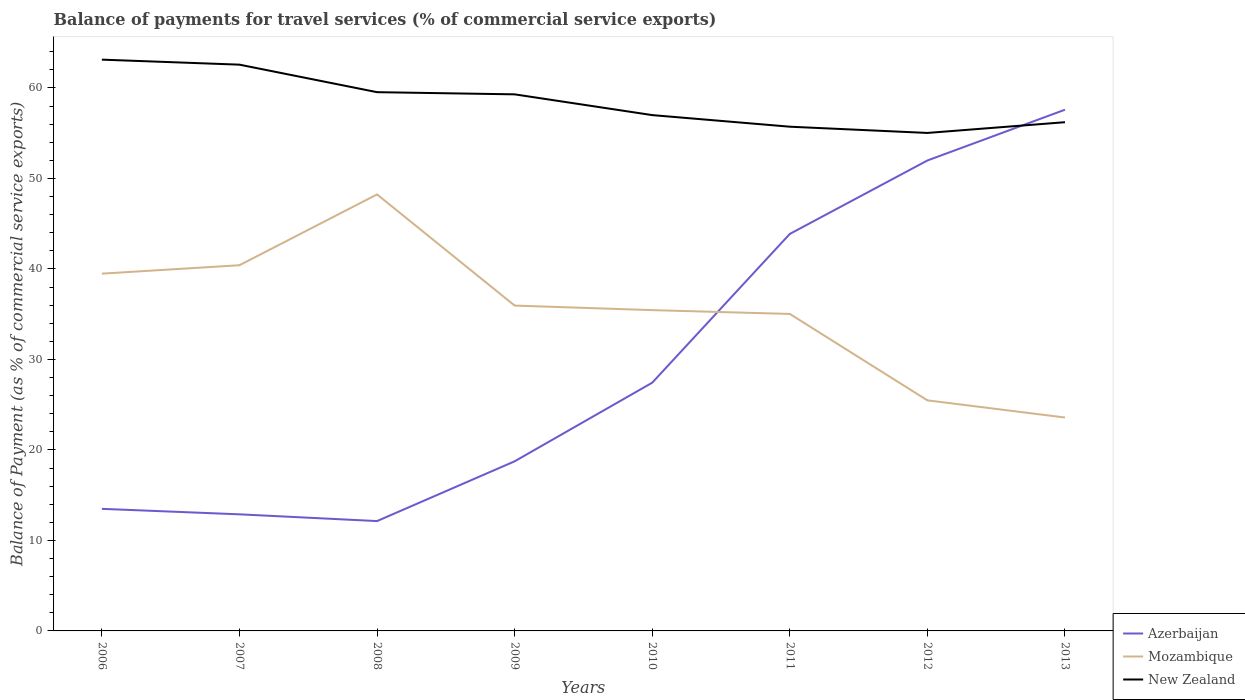How many different coloured lines are there?
Keep it short and to the point. 3. Does the line corresponding to New Zealand intersect with the line corresponding to Azerbaijan?
Provide a succinct answer. Yes. Is the number of lines equal to the number of legend labels?
Your response must be concise. Yes. Across all years, what is the maximum balance of payments for travel services in Azerbaijan?
Your response must be concise. 12.14. What is the total balance of payments for travel services in New Zealand in the graph?
Your answer should be compact. 7.41. What is the difference between the highest and the second highest balance of payments for travel services in New Zealand?
Provide a short and direct response. 8.1. What is the difference between the highest and the lowest balance of payments for travel services in New Zealand?
Your answer should be very brief. 4. How many lines are there?
Your response must be concise. 3. How many years are there in the graph?
Keep it short and to the point. 8. Does the graph contain grids?
Offer a terse response. No. How are the legend labels stacked?
Your answer should be very brief. Vertical. What is the title of the graph?
Your answer should be very brief. Balance of payments for travel services (% of commercial service exports). What is the label or title of the Y-axis?
Provide a succinct answer. Balance of Payment (as % of commercial service exports). What is the Balance of Payment (as % of commercial service exports) in Azerbaijan in 2006?
Offer a terse response. 13.49. What is the Balance of Payment (as % of commercial service exports) of Mozambique in 2006?
Make the answer very short. 39.48. What is the Balance of Payment (as % of commercial service exports) in New Zealand in 2006?
Provide a short and direct response. 63.13. What is the Balance of Payment (as % of commercial service exports) in Azerbaijan in 2007?
Provide a short and direct response. 12.88. What is the Balance of Payment (as % of commercial service exports) in Mozambique in 2007?
Offer a very short reply. 40.41. What is the Balance of Payment (as % of commercial service exports) in New Zealand in 2007?
Provide a short and direct response. 62.57. What is the Balance of Payment (as % of commercial service exports) in Azerbaijan in 2008?
Make the answer very short. 12.14. What is the Balance of Payment (as % of commercial service exports) in Mozambique in 2008?
Offer a very short reply. 48.23. What is the Balance of Payment (as % of commercial service exports) of New Zealand in 2008?
Provide a succinct answer. 59.53. What is the Balance of Payment (as % of commercial service exports) of Azerbaijan in 2009?
Your answer should be compact. 18.74. What is the Balance of Payment (as % of commercial service exports) of Mozambique in 2009?
Offer a terse response. 35.95. What is the Balance of Payment (as % of commercial service exports) in New Zealand in 2009?
Give a very brief answer. 59.29. What is the Balance of Payment (as % of commercial service exports) of Azerbaijan in 2010?
Your answer should be compact. 27.43. What is the Balance of Payment (as % of commercial service exports) of Mozambique in 2010?
Keep it short and to the point. 35.45. What is the Balance of Payment (as % of commercial service exports) in New Zealand in 2010?
Make the answer very short. 57. What is the Balance of Payment (as % of commercial service exports) of Azerbaijan in 2011?
Your response must be concise. 43.87. What is the Balance of Payment (as % of commercial service exports) of Mozambique in 2011?
Your answer should be very brief. 35.03. What is the Balance of Payment (as % of commercial service exports) of New Zealand in 2011?
Your answer should be compact. 55.72. What is the Balance of Payment (as % of commercial service exports) in Azerbaijan in 2012?
Provide a short and direct response. 51.98. What is the Balance of Payment (as % of commercial service exports) in Mozambique in 2012?
Your response must be concise. 25.48. What is the Balance of Payment (as % of commercial service exports) of New Zealand in 2012?
Make the answer very short. 55.03. What is the Balance of Payment (as % of commercial service exports) of Azerbaijan in 2013?
Offer a terse response. 57.59. What is the Balance of Payment (as % of commercial service exports) in Mozambique in 2013?
Provide a succinct answer. 23.58. What is the Balance of Payment (as % of commercial service exports) in New Zealand in 2013?
Offer a very short reply. 56.21. Across all years, what is the maximum Balance of Payment (as % of commercial service exports) in Azerbaijan?
Provide a short and direct response. 57.59. Across all years, what is the maximum Balance of Payment (as % of commercial service exports) of Mozambique?
Ensure brevity in your answer.  48.23. Across all years, what is the maximum Balance of Payment (as % of commercial service exports) of New Zealand?
Offer a very short reply. 63.13. Across all years, what is the minimum Balance of Payment (as % of commercial service exports) of Azerbaijan?
Provide a short and direct response. 12.14. Across all years, what is the minimum Balance of Payment (as % of commercial service exports) in Mozambique?
Offer a very short reply. 23.58. Across all years, what is the minimum Balance of Payment (as % of commercial service exports) in New Zealand?
Make the answer very short. 55.03. What is the total Balance of Payment (as % of commercial service exports) in Azerbaijan in the graph?
Your answer should be compact. 238.13. What is the total Balance of Payment (as % of commercial service exports) of Mozambique in the graph?
Offer a terse response. 283.61. What is the total Balance of Payment (as % of commercial service exports) of New Zealand in the graph?
Your answer should be compact. 468.48. What is the difference between the Balance of Payment (as % of commercial service exports) of Azerbaijan in 2006 and that in 2007?
Provide a short and direct response. 0.61. What is the difference between the Balance of Payment (as % of commercial service exports) in Mozambique in 2006 and that in 2007?
Provide a succinct answer. -0.93. What is the difference between the Balance of Payment (as % of commercial service exports) in New Zealand in 2006 and that in 2007?
Provide a succinct answer. 0.55. What is the difference between the Balance of Payment (as % of commercial service exports) of Azerbaijan in 2006 and that in 2008?
Give a very brief answer. 1.35. What is the difference between the Balance of Payment (as % of commercial service exports) in Mozambique in 2006 and that in 2008?
Keep it short and to the point. -8.75. What is the difference between the Balance of Payment (as % of commercial service exports) of New Zealand in 2006 and that in 2008?
Your answer should be very brief. 3.59. What is the difference between the Balance of Payment (as % of commercial service exports) in Azerbaijan in 2006 and that in 2009?
Your answer should be very brief. -5.25. What is the difference between the Balance of Payment (as % of commercial service exports) in Mozambique in 2006 and that in 2009?
Your answer should be compact. 3.53. What is the difference between the Balance of Payment (as % of commercial service exports) of New Zealand in 2006 and that in 2009?
Ensure brevity in your answer.  3.83. What is the difference between the Balance of Payment (as % of commercial service exports) of Azerbaijan in 2006 and that in 2010?
Give a very brief answer. -13.94. What is the difference between the Balance of Payment (as % of commercial service exports) in Mozambique in 2006 and that in 2010?
Make the answer very short. 4.03. What is the difference between the Balance of Payment (as % of commercial service exports) of New Zealand in 2006 and that in 2010?
Your answer should be very brief. 6.13. What is the difference between the Balance of Payment (as % of commercial service exports) of Azerbaijan in 2006 and that in 2011?
Provide a succinct answer. -30.38. What is the difference between the Balance of Payment (as % of commercial service exports) of Mozambique in 2006 and that in 2011?
Your answer should be compact. 4.45. What is the difference between the Balance of Payment (as % of commercial service exports) in New Zealand in 2006 and that in 2011?
Keep it short and to the point. 7.41. What is the difference between the Balance of Payment (as % of commercial service exports) in Azerbaijan in 2006 and that in 2012?
Your response must be concise. -38.49. What is the difference between the Balance of Payment (as % of commercial service exports) in Mozambique in 2006 and that in 2012?
Ensure brevity in your answer.  14. What is the difference between the Balance of Payment (as % of commercial service exports) of New Zealand in 2006 and that in 2012?
Provide a succinct answer. 8.1. What is the difference between the Balance of Payment (as % of commercial service exports) of Azerbaijan in 2006 and that in 2013?
Keep it short and to the point. -44.11. What is the difference between the Balance of Payment (as % of commercial service exports) of Mozambique in 2006 and that in 2013?
Your answer should be very brief. 15.9. What is the difference between the Balance of Payment (as % of commercial service exports) of New Zealand in 2006 and that in 2013?
Provide a succinct answer. 6.91. What is the difference between the Balance of Payment (as % of commercial service exports) of Azerbaijan in 2007 and that in 2008?
Provide a short and direct response. 0.75. What is the difference between the Balance of Payment (as % of commercial service exports) in Mozambique in 2007 and that in 2008?
Provide a succinct answer. -7.82. What is the difference between the Balance of Payment (as % of commercial service exports) in New Zealand in 2007 and that in 2008?
Provide a succinct answer. 3.04. What is the difference between the Balance of Payment (as % of commercial service exports) of Azerbaijan in 2007 and that in 2009?
Ensure brevity in your answer.  -5.86. What is the difference between the Balance of Payment (as % of commercial service exports) in Mozambique in 2007 and that in 2009?
Provide a short and direct response. 4.46. What is the difference between the Balance of Payment (as % of commercial service exports) in New Zealand in 2007 and that in 2009?
Give a very brief answer. 3.28. What is the difference between the Balance of Payment (as % of commercial service exports) of Azerbaijan in 2007 and that in 2010?
Give a very brief answer. -14.55. What is the difference between the Balance of Payment (as % of commercial service exports) in Mozambique in 2007 and that in 2010?
Your answer should be compact. 4.96. What is the difference between the Balance of Payment (as % of commercial service exports) in New Zealand in 2007 and that in 2010?
Offer a terse response. 5.57. What is the difference between the Balance of Payment (as % of commercial service exports) of Azerbaijan in 2007 and that in 2011?
Make the answer very short. -30.99. What is the difference between the Balance of Payment (as % of commercial service exports) of Mozambique in 2007 and that in 2011?
Your answer should be compact. 5.38. What is the difference between the Balance of Payment (as % of commercial service exports) of New Zealand in 2007 and that in 2011?
Offer a terse response. 6.86. What is the difference between the Balance of Payment (as % of commercial service exports) in Azerbaijan in 2007 and that in 2012?
Offer a terse response. -39.1. What is the difference between the Balance of Payment (as % of commercial service exports) of Mozambique in 2007 and that in 2012?
Provide a short and direct response. 14.93. What is the difference between the Balance of Payment (as % of commercial service exports) in New Zealand in 2007 and that in 2012?
Your response must be concise. 7.55. What is the difference between the Balance of Payment (as % of commercial service exports) in Azerbaijan in 2007 and that in 2013?
Make the answer very short. -44.71. What is the difference between the Balance of Payment (as % of commercial service exports) in Mozambique in 2007 and that in 2013?
Make the answer very short. 16.83. What is the difference between the Balance of Payment (as % of commercial service exports) in New Zealand in 2007 and that in 2013?
Make the answer very short. 6.36. What is the difference between the Balance of Payment (as % of commercial service exports) of Azerbaijan in 2008 and that in 2009?
Ensure brevity in your answer.  -6.6. What is the difference between the Balance of Payment (as % of commercial service exports) in Mozambique in 2008 and that in 2009?
Keep it short and to the point. 12.28. What is the difference between the Balance of Payment (as % of commercial service exports) in New Zealand in 2008 and that in 2009?
Ensure brevity in your answer.  0.24. What is the difference between the Balance of Payment (as % of commercial service exports) in Azerbaijan in 2008 and that in 2010?
Keep it short and to the point. -15.29. What is the difference between the Balance of Payment (as % of commercial service exports) of Mozambique in 2008 and that in 2010?
Your answer should be very brief. 12.79. What is the difference between the Balance of Payment (as % of commercial service exports) in New Zealand in 2008 and that in 2010?
Give a very brief answer. 2.53. What is the difference between the Balance of Payment (as % of commercial service exports) of Azerbaijan in 2008 and that in 2011?
Provide a succinct answer. -31.73. What is the difference between the Balance of Payment (as % of commercial service exports) in Mozambique in 2008 and that in 2011?
Your answer should be very brief. 13.21. What is the difference between the Balance of Payment (as % of commercial service exports) in New Zealand in 2008 and that in 2011?
Provide a short and direct response. 3.81. What is the difference between the Balance of Payment (as % of commercial service exports) of Azerbaijan in 2008 and that in 2012?
Make the answer very short. -39.85. What is the difference between the Balance of Payment (as % of commercial service exports) in Mozambique in 2008 and that in 2012?
Your response must be concise. 22.76. What is the difference between the Balance of Payment (as % of commercial service exports) of New Zealand in 2008 and that in 2012?
Offer a terse response. 4.5. What is the difference between the Balance of Payment (as % of commercial service exports) of Azerbaijan in 2008 and that in 2013?
Your answer should be very brief. -45.46. What is the difference between the Balance of Payment (as % of commercial service exports) in Mozambique in 2008 and that in 2013?
Your answer should be compact. 24.65. What is the difference between the Balance of Payment (as % of commercial service exports) of New Zealand in 2008 and that in 2013?
Offer a terse response. 3.32. What is the difference between the Balance of Payment (as % of commercial service exports) of Azerbaijan in 2009 and that in 2010?
Your response must be concise. -8.69. What is the difference between the Balance of Payment (as % of commercial service exports) of Mozambique in 2009 and that in 2010?
Make the answer very short. 0.5. What is the difference between the Balance of Payment (as % of commercial service exports) of New Zealand in 2009 and that in 2010?
Provide a short and direct response. 2.29. What is the difference between the Balance of Payment (as % of commercial service exports) in Azerbaijan in 2009 and that in 2011?
Offer a very short reply. -25.13. What is the difference between the Balance of Payment (as % of commercial service exports) of Mozambique in 2009 and that in 2011?
Provide a short and direct response. 0.92. What is the difference between the Balance of Payment (as % of commercial service exports) of New Zealand in 2009 and that in 2011?
Make the answer very short. 3.58. What is the difference between the Balance of Payment (as % of commercial service exports) in Azerbaijan in 2009 and that in 2012?
Provide a succinct answer. -33.24. What is the difference between the Balance of Payment (as % of commercial service exports) of Mozambique in 2009 and that in 2012?
Your answer should be very brief. 10.47. What is the difference between the Balance of Payment (as % of commercial service exports) in New Zealand in 2009 and that in 2012?
Ensure brevity in your answer.  4.26. What is the difference between the Balance of Payment (as % of commercial service exports) of Azerbaijan in 2009 and that in 2013?
Make the answer very short. -38.85. What is the difference between the Balance of Payment (as % of commercial service exports) of Mozambique in 2009 and that in 2013?
Offer a terse response. 12.37. What is the difference between the Balance of Payment (as % of commercial service exports) in New Zealand in 2009 and that in 2013?
Your response must be concise. 3.08. What is the difference between the Balance of Payment (as % of commercial service exports) of Azerbaijan in 2010 and that in 2011?
Give a very brief answer. -16.44. What is the difference between the Balance of Payment (as % of commercial service exports) in Mozambique in 2010 and that in 2011?
Offer a terse response. 0.42. What is the difference between the Balance of Payment (as % of commercial service exports) in New Zealand in 2010 and that in 2011?
Provide a succinct answer. 1.28. What is the difference between the Balance of Payment (as % of commercial service exports) in Azerbaijan in 2010 and that in 2012?
Offer a terse response. -24.55. What is the difference between the Balance of Payment (as % of commercial service exports) in Mozambique in 2010 and that in 2012?
Offer a very short reply. 9.97. What is the difference between the Balance of Payment (as % of commercial service exports) in New Zealand in 2010 and that in 2012?
Your response must be concise. 1.97. What is the difference between the Balance of Payment (as % of commercial service exports) of Azerbaijan in 2010 and that in 2013?
Provide a succinct answer. -30.17. What is the difference between the Balance of Payment (as % of commercial service exports) in Mozambique in 2010 and that in 2013?
Ensure brevity in your answer.  11.87. What is the difference between the Balance of Payment (as % of commercial service exports) of New Zealand in 2010 and that in 2013?
Your response must be concise. 0.78. What is the difference between the Balance of Payment (as % of commercial service exports) in Azerbaijan in 2011 and that in 2012?
Ensure brevity in your answer.  -8.11. What is the difference between the Balance of Payment (as % of commercial service exports) in Mozambique in 2011 and that in 2012?
Provide a succinct answer. 9.55. What is the difference between the Balance of Payment (as % of commercial service exports) in New Zealand in 2011 and that in 2012?
Your response must be concise. 0.69. What is the difference between the Balance of Payment (as % of commercial service exports) in Azerbaijan in 2011 and that in 2013?
Your response must be concise. -13.72. What is the difference between the Balance of Payment (as % of commercial service exports) of Mozambique in 2011 and that in 2013?
Provide a succinct answer. 11.45. What is the difference between the Balance of Payment (as % of commercial service exports) of New Zealand in 2011 and that in 2013?
Ensure brevity in your answer.  -0.5. What is the difference between the Balance of Payment (as % of commercial service exports) of Azerbaijan in 2012 and that in 2013?
Your answer should be compact. -5.61. What is the difference between the Balance of Payment (as % of commercial service exports) of Mozambique in 2012 and that in 2013?
Your answer should be compact. 1.9. What is the difference between the Balance of Payment (as % of commercial service exports) of New Zealand in 2012 and that in 2013?
Your response must be concise. -1.19. What is the difference between the Balance of Payment (as % of commercial service exports) of Azerbaijan in 2006 and the Balance of Payment (as % of commercial service exports) of Mozambique in 2007?
Keep it short and to the point. -26.92. What is the difference between the Balance of Payment (as % of commercial service exports) of Azerbaijan in 2006 and the Balance of Payment (as % of commercial service exports) of New Zealand in 2007?
Offer a terse response. -49.08. What is the difference between the Balance of Payment (as % of commercial service exports) in Mozambique in 2006 and the Balance of Payment (as % of commercial service exports) in New Zealand in 2007?
Your response must be concise. -23.09. What is the difference between the Balance of Payment (as % of commercial service exports) in Azerbaijan in 2006 and the Balance of Payment (as % of commercial service exports) in Mozambique in 2008?
Your answer should be compact. -34.74. What is the difference between the Balance of Payment (as % of commercial service exports) of Azerbaijan in 2006 and the Balance of Payment (as % of commercial service exports) of New Zealand in 2008?
Offer a very short reply. -46.04. What is the difference between the Balance of Payment (as % of commercial service exports) of Mozambique in 2006 and the Balance of Payment (as % of commercial service exports) of New Zealand in 2008?
Ensure brevity in your answer.  -20.05. What is the difference between the Balance of Payment (as % of commercial service exports) of Azerbaijan in 2006 and the Balance of Payment (as % of commercial service exports) of Mozambique in 2009?
Offer a terse response. -22.46. What is the difference between the Balance of Payment (as % of commercial service exports) in Azerbaijan in 2006 and the Balance of Payment (as % of commercial service exports) in New Zealand in 2009?
Offer a very short reply. -45.8. What is the difference between the Balance of Payment (as % of commercial service exports) of Mozambique in 2006 and the Balance of Payment (as % of commercial service exports) of New Zealand in 2009?
Ensure brevity in your answer.  -19.81. What is the difference between the Balance of Payment (as % of commercial service exports) in Azerbaijan in 2006 and the Balance of Payment (as % of commercial service exports) in Mozambique in 2010?
Give a very brief answer. -21.96. What is the difference between the Balance of Payment (as % of commercial service exports) of Azerbaijan in 2006 and the Balance of Payment (as % of commercial service exports) of New Zealand in 2010?
Your answer should be very brief. -43.51. What is the difference between the Balance of Payment (as % of commercial service exports) of Mozambique in 2006 and the Balance of Payment (as % of commercial service exports) of New Zealand in 2010?
Give a very brief answer. -17.52. What is the difference between the Balance of Payment (as % of commercial service exports) in Azerbaijan in 2006 and the Balance of Payment (as % of commercial service exports) in Mozambique in 2011?
Your response must be concise. -21.54. What is the difference between the Balance of Payment (as % of commercial service exports) of Azerbaijan in 2006 and the Balance of Payment (as % of commercial service exports) of New Zealand in 2011?
Offer a very short reply. -42.23. What is the difference between the Balance of Payment (as % of commercial service exports) of Mozambique in 2006 and the Balance of Payment (as % of commercial service exports) of New Zealand in 2011?
Provide a succinct answer. -16.24. What is the difference between the Balance of Payment (as % of commercial service exports) in Azerbaijan in 2006 and the Balance of Payment (as % of commercial service exports) in Mozambique in 2012?
Offer a very short reply. -11.99. What is the difference between the Balance of Payment (as % of commercial service exports) in Azerbaijan in 2006 and the Balance of Payment (as % of commercial service exports) in New Zealand in 2012?
Ensure brevity in your answer.  -41.54. What is the difference between the Balance of Payment (as % of commercial service exports) in Mozambique in 2006 and the Balance of Payment (as % of commercial service exports) in New Zealand in 2012?
Offer a very short reply. -15.55. What is the difference between the Balance of Payment (as % of commercial service exports) of Azerbaijan in 2006 and the Balance of Payment (as % of commercial service exports) of Mozambique in 2013?
Make the answer very short. -10.09. What is the difference between the Balance of Payment (as % of commercial service exports) of Azerbaijan in 2006 and the Balance of Payment (as % of commercial service exports) of New Zealand in 2013?
Your answer should be compact. -42.72. What is the difference between the Balance of Payment (as % of commercial service exports) in Mozambique in 2006 and the Balance of Payment (as % of commercial service exports) in New Zealand in 2013?
Keep it short and to the point. -16.73. What is the difference between the Balance of Payment (as % of commercial service exports) of Azerbaijan in 2007 and the Balance of Payment (as % of commercial service exports) of Mozambique in 2008?
Offer a terse response. -35.35. What is the difference between the Balance of Payment (as % of commercial service exports) in Azerbaijan in 2007 and the Balance of Payment (as % of commercial service exports) in New Zealand in 2008?
Provide a short and direct response. -46.65. What is the difference between the Balance of Payment (as % of commercial service exports) in Mozambique in 2007 and the Balance of Payment (as % of commercial service exports) in New Zealand in 2008?
Make the answer very short. -19.12. What is the difference between the Balance of Payment (as % of commercial service exports) in Azerbaijan in 2007 and the Balance of Payment (as % of commercial service exports) in Mozambique in 2009?
Your answer should be very brief. -23.07. What is the difference between the Balance of Payment (as % of commercial service exports) of Azerbaijan in 2007 and the Balance of Payment (as % of commercial service exports) of New Zealand in 2009?
Ensure brevity in your answer.  -46.41. What is the difference between the Balance of Payment (as % of commercial service exports) in Mozambique in 2007 and the Balance of Payment (as % of commercial service exports) in New Zealand in 2009?
Give a very brief answer. -18.88. What is the difference between the Balance of Payment (as % of commercial service exports) in Azerbaijan in 2007 and the Balance of Payment (as % of commercial service exports) in Mozambique in 2010?
Your response must be concise. -22.56. What is the difference between the Balance of Payment (as % of commercial service exports) in Azerbaijan in 2007 and the Balance of Payment (as % of commercial service exports) in New Zealand in 2010?
Give a very brief answer. -44.11. What is the difference between the Balance of Payment (as % of commercial service exports) of Mozambique in 2007 and the Balance of Payment (as % of commercial service exports) of New Zealand in 2010?
Your answer should be very brief. -16.59. What is the difference between the Balance of Payment (as % of commercial service exports) in Azerbaijan in 2007 and the Balance of Payment (as % of commercial service exports) in Mozambique in 2011?
Provide a succinct answer. -22.14. What is the difference between the Balance of Payment (as % of commercial service exports) in Azerbaijan in 2007 and the Balance of Payment (as % of commercial service exports) in New Zealand in 2011?
Offer a terse response. -42.83. What is the difference between the Balance of Payment (as % of commercial service exports) in Mozambique in 2007 and the Balance of Payment (as % of commercial service exports) in New Zealand in 2011?
Offer a very short reply. -15.31. What is the difference between the Balance of Payment (as % of commercial service exports) in Azerbaijan in 2007 and the Balance of Payment (as % of commercial service exports) in Mozambique in 2012?
Ensure brevity in your answer.  -12.59. What is the difference between the Balance of Payment (as % of commercial service exports) in Azerbaijan in 2007 and the Balance of Payment (as % of commercial service exports) in New Zealand in 2012?
Give a very brief answer. -42.14. What is the difference between the Balance of Payment (as % of commercial service exports) in Mozambique in 2007 and the Balance of Payment (as % of commercial service exports) in New Zealand in 2012?
Keep it short and to the point. -14.62. What is the difference between the Balance of Payment (as % of commercial service exports) in Azerbaijan in 2007 and the Balance of Payment (as % of commercial service exports) in Mozambique in 2013?
Offer a very short reply. -10.7. What is the difference between the Balance of Payment (as % of commercial service exports) in Azerbaijan in 2007 and the Balance of Payment (as % of commercial service exports) in New Zealand in 2013?
Your answer should be very brief. -43.33. What is the difference between the Balance of Payment (as % of commercial service exports) of Mozambique in 2007 and the Balance of Payment (as % of commercial service exports) of New Zealand in 2013?
Provide a short and direct response. -15.8. What is the difference between the Balance of Payment (as % of commercial service exports) of Azerbaijan in 2008 and the Balance of Payment (as % of commercial service exports) of Mozambique in 2009?
Keep it short and to the point. -23.81. What is the difference between the Balance of Payment (as % of commercial service exports) in Azerbaijan in 2008 and the Balance of Payment (as % of commercial service exports) in New Zealand in 2009?
Your response must be concise. -47.15. What is the difference between the Balance of Payment (as % of commercial service exports) of Mozambique in 2008 and the Balance of Payment (as % of commercial service exports) of New Zealand in 2009?
Provide a short and direct response. -11.06. What is the difference between the Balance of Payment (as % of commercial service exports) in Azerbaijan in 2008 and the Balance of Payment (as % of commercial service exports) in Mozambique in 2010?
Give a very brief answer. -23.31. What is the difference between the Balance of Payment (as % of commercial service exports) of Azerbaijan in 2008 and the Balance of Payment (as % of commercial service exports) of New Zealand in 2010?
Ensure brevity in your answer.  -44.86. What is the difference between the Balance of Payment (as % of commercial service exports) of Mozambique in 2008 and the Balance of Payment (as % of commercial service exports) of New Zealand in 2010?
Keep it short and to the point. -8.76. What is the difference between the Balance of Payment (as % of commercial service exports) of Azerbaijan in 2008 and the Balance of Payment (as % of commercial service exports) of Mozambique in 2011?
Give a very brief answer. -22.89. What is the difference between the Balance of Payment (as % of commercial service exports) in Azerbaijan in 2008 and the Balance of Payment (as % of commercial service exports) in New Zealand in 2011?
Provide a short and direct response. -43.58. What is the difference between the Balance of Payment (as % of commercial service exports) in Mozambique in 2008 and the Balance of Payment (as % of commercial service exports) in New Zealand in 2011?
Make the answer very short. -7.48. What is the difference between the Balance of Payment (as % of commercial service exports) in Azerbaijan in 2008 and the Balance of Payment (as % of commercial service exports) in Mozambique in 2012?
Offer a terse response. -13.34. What is the difference between the Balance of Payment (as % of commercial service exports) of Azerbaijan in 2008 and the Balance of Payment (as % of commercial service exports) of New Zealand in 2012?
Your response must be concise. -42.89. What is the difference between the Balance of Payment (as % of commercial service exports) in Mozambique in 2008 and the Balance of Payment (as % of commercial service exports) in New Zealand in 2012?
Provide a short and direct response. -6.79. What is the difference between the Balance of Payment (as % of commercial service exports) of Azerbaijan in 2008 and the Balance of Payment (as % of commercial service exports) of Mozambique in 2013?
Your answer should be compact. -11.44. What is the difference between the Balance of Payment (as % of commercial service exports) of Azerbaijan in 2008 and the Balance of Payment (as % of commercial service exports) of New Zealand in 2013?
Your answer should be compact. -44.08. What is the difference between the Balance of Payment (as % of commercial service exports) of Mozambique in 2008 and the Balance of Payment (as % of commercial service exports) of New Zealand in 2013?
Ensure brevity in your answer.  -7.98. What is the difference between the Balance of Payment (as % of commercial service exports) in Azerbaijan in 2009 and the Balance of Payment (as % of commercial service exports) in Mozambique in 2010?
Make the answer very short. -16.71. What is the difference between the Balance of Payment (as % of commercial service exports) of Azerbaijan in 2009 and the Balance of Payment (as % of commercial service exports) of New Zealand in 2010?
Give a very brief answer. -38.26. What is the difference between the Balance of Payment (as % of commercial service exports) in Mozambique in 2009 and the Balance of Payment (as % of commercial service exports) in New Zealand in 2010?
Make the answer very short. -21.05. What is the difference between the Balance of Payment (as % of commercial service exports) of Azerbaijan in 2009 and the Balance of Payment (as % of commercial service exports) of Mozambique in 2011?
Offer a terse response. -16.29. What is the difference between the Balance of Payment (as % of commercial service exports) of Azerbaijan in 2009 and the Balance of Payment (as % of commercial service exports) of New Zealand in 2011?
Keep it short and to the point. -36.97. What is the difference between the Balance of Payment (as % of commercial service exports) of Mozambique in 2009 and the Balance of Payment (as % of commercial service exports) of New Zealand in 2011?
Provide a short and direct response. -19.77. What is the difference between the Balance of Payment (as % of commercial service exports) in Azerbaijan in 2009 and the Balance of Payment (as % of commercial service exports) in Mozambique in 2012?
Make the answer very short. -6.74. What is the difference between the Balance of Payment (as % of commercial service exports) of Azerbaijan in 2009 and the Balance of Payment (as % of commercial service exports) of New Zealand in 2012?
Your response must be concise. -36.29. What is the difference between the Balance of Payment (as % of commercial service exports) of Mozambique in 2009 and the Balance of Payment (as % of commercial service exports) of New Zealand in 2012?
Make the answer very short. -19.08. What is the difference between the Balance of Payment (as % of commercial service exports) of Azerbaijan in 2009 and the Balance of Payment (as % of commercial service exports) of Mozambique in 2013?
Keep it short and to the point. -4.84. What is the difference between the Balance of Payment (as % of commercial service exports) in Azerbaijan in 2009 and the Balance of Payment (as % of commercial service exports) in New Zealand in 2013?
Ensure brevity in your answer.  -37.47. What is the difference between the Balance of Payment (as % of commercial service exports) of Mozambique in 2009 and the Balance of Payment (as % of commercial service exports) of New Zealand in 2013?
Offer a very short reply. -20.26. What is the difference between the Balance of Payment (as % of commercial service exports) of Azerbaijan in 2010 and the Balance of Payment (as % of commercial service exports) of Mozambique in 2011?
Your answer should be very brief. -7.6. What is the difference between the Balance of Payment (as % of commercial service exports) of Azerbaijan in 2010 and the Balance of Payment (as % of commercial service exports) of New Zealand in 2011?
Ensure brevity in your answer.  -28.29. What is the difference between the Balance of Payment (as % of commercial service exports) of Mozambique in 2010 and the Balance of Payment (as % of commercial service exports) of New Zealand in 2011?
Your answer should be very brief. -20.27. What is the difference between the Balance of Payment (as % of commercial service exports) of Azerbaijan in 2010 and the Balance of Payment (as % of commercial service exports) of Mozambique in 2012?
Provide a succinct answer. 1.95. What is the difference between the Balance of Payment (as % of commercial service exports) in Azerbaijan in 2010 and the Balance of Payment (as % of commercial service exports) in New Zealand in 2012?
Give a very brief answer. -27.6. What is the difference between the Balance of Payment (as % of commercial service exports) of Mozambique in 2010 and the Balance of Payment (as % of commercial service exports) of New Zealand in 2012?
Provide a short and direct response. -19.58. What is the difference between the Balance of Payment (as % of commercial service exports) of Azerbaijan in 2010 and the Balance of Payment (as % of commercial service exports) of Mozambique in 2013?
Keep it short and to the point. 3.85. What is the difference between the Balance of Payment (as % of commercial service exports) in Azerbaijan in 2010 and the Balance of Payment (as % of commercial service exports) in New Zealand in 2013?
Your response must be concise. -28.78. What is the difference between the Balance of Payment (as % of commercial service exports) in Mozambique in 2010 and the Balance of Payment (as % of commercial service exports) in New Zealand in 2013?
Ensure brevity in your answer.  -20.77. What is the difference between the Balance of Payment (as % of commercial service exports) of Azerbaijan in 2011 and the Balance of Payment (as % of commercial service exports) of Mozambique in 2012?
Offer a terse response. 18.39. What is the difference between the Balance of Payment (as % of commercial service exports) in Azerbaijan in 2011 and the Balance of Payment (as % of commercial service exports) in New Zealand in 2012?
Offer a terse response. -11.16. What is the difference between the Balance of Payment (as % of commercial service exports) of Mozambique in 2011 and the Balance of Payment (as % of commercial service exports) of New Zealand in 2012?
Keep it short and to the point. -20. What is the difference between the Balance of Payment (as % of commercial service exports) of Azerbaijan in 2011 and the Balance of Payment (as % of commercial service exports) of Mozambique in 2013?
Offer a terse response. 20.29. What is the difference between the Balance of Payment (as % of commercial service exports) of Azerbaijan in 2011 and the Balance of Payment (as % of commercial service exports) of New Zealand in 2013?
Provide a succinct answer. -12.34. What is the difference between the Balance of Payment (as % of commercial service exports) of Mozambique in 2011 and the Balance of Payment (as % of commercial service exports) of New Zealand in 2013?
Your answer should be very brief. -21.19. What is the difference between the Balance of Payment (as % of commercial service exports) in Azerbaijan in 2012 and the Balance of Payment (as % of commercial service exports) in Mozambique in 2013?
Make the answer very short. 28.4. What is the difference between the Balance of Payment (as % of commercial service exports) in Azerbaijan in 2012 and the Balance of Payment (as % of commercial service exports) in New Zealand in 2013?
Make the answer very short. -4.23. What is the difference between the Balance of Payment (as % of commercial service exports) in Mozambique in 2012 and the Balance of Payment (as % of commercial service exports) in New Zealand in 2013?
Ensure brevity in your answer.  -30.74. What is the average Balance of Payment (as % of commercial service exports) of Azerbaijan per year?
Your answer should be compact. 29.77. What is the average Balance of Payment (as % of commercial service exports) of Mozambique per year?
Offer a very short reply. 35.45. What is the average Balance of Payment (as % of commercial service exports) of New Zealand per year?
Keep it short and to the point. 58.56. In the year 2006, what is the difference between the Balance of Payment (as % of commercial service exports) in Azerbaijan and Balance of Payment (as % of commercial service exports) in Mozambique?
Provide a succinct answer. -25.99. In the year 2006, what is the difference between the Balance of Payment (as % of commercial service exports) in Azerbaijan and Balance of Payment (as % of commercial service exports) in New Zealand?
Provide a succinct answer. -49.64. In the year 2006, what is the difference between the Balance of Payment (as % of commercial service exports) in Mozambique and Balance of Payment (as % of commercial service exports) in New Zealand?
Offer a terse response. -23.65. In the year 2007, what is the difference between the Balance of Payment (as % of commercial service exports) of Azerbaijan and Balance of Payment (as % of commercial service exports) of Mozambique?
Your answer should be very brief. -27.53. In the year 2007, what is the difference between the Balance of Payment (as % of commercial service exports) of Azerbaijan and Balance of Payment (as % of commercial service exports) of New Zealand?
Give a very brief answer. -49.69. In the year 2007, what is the difference between the Balance of Payment (as % of commercial service exports) in Mozambique and Balance of Payment (as % of commercial service exports) in New Zealand?
Give a very brief answer. -22.16. In the year 2008, what is the difference between the Balance of Payment (as % of commercial service exports) in Azerbaijan and Balance of Payment (as % of commercial service exports) in Mozambique?
Provide a succinct answer. -36.1. In the year 2008, what is the difference between the Balance of Payment (as % of commercial service exports) of Azerbaijan and Balance of Payment (as % of commercial service exports) of New Zealand?
Offer a terse response. -47.39. In the year 2008, what is the difference between the Balance of Payment (as % of commercial service exports) in Mozambique and Balance of Payment (as % of commercial service exports) in New Zealand?
Your response must be concise. -11.3. In the year 2009, what is the difference between the Balance of Payment (as % of commercial service exports) of Azerbaijan and Balance of Payment (as % of commercial service exports) of Mozambique?
Offer a very short reply. -17.21. In the year 2009, what is the difference between the Balance of Payment (as % of commercial service exports) in Azerbaijan and Balance of Payment (as % of commercial service exports) in New Zealand?
Keep it short and to the point. -40.55. In the year 2009, what is the difference between the Balance of Payment (as % of commercial service exports) of Mozambique and Balance of Payment (as % of commercial service exports) of New Zealand?
Your response must be concise. -23.34. In the year 2010, what is the difference between the Balance of Payment (as % of commercial service exports) of Azerbaijan and Balance of Payment (as % of commercial service exports) of Mozambique?
Keep it short and to the point. -8.02. In the year 2010, what is the difference between the Balance of Payment (as % of commercial service exports) of Azerbaijan and Balance of Payment (as % of commercial service exports) of New Zealand?
Ensure brevity in your answer.  -29.57. In the year 2010, what is the difference between the Balance of Payment (as % of commercial service exports) of Mozambique and Balance of Payment (as % of commercial service exports) of New Zealand?
Give a very brief answer. -21.55. In the year 2011, what is the difference between the Balance of Payment (as % of commercial service exports) of Azerbaijan and Balance of Payment (as % of commercial service exports) of Mozambique?
Your response must be concise. 8.84. In the year 2011, what is the difference between the Balance of Payment (as % of commercial service exports) of Azerbaijan and Balance of Payment (as % of commercial service exports) of New Zealand?
Provide a succinct answer. -11.85. In the year 2011, what is the difference between the Balance of Payment (as % of commercial service exports) of Mozambique and Balance of Payment (as % of commercial service exports) of New Zealand?
Offer a very short reply. -20.69. In the year 2012, what is the difference between the Balance of Payment (as % of commercial service exports) in Azerbaijan and Balance of Payment (as % of commercial service exports) in Mozambique?
Provide a short and direct response. 26.5. In the year 2012, what is the difference between the Balance of Payment (as % of commercial service exports) of Azerbaijan and Balance of Payment (as % of commercial service exports) of New Zealand?
Ensure brevity in your answer.  -3.04. In the year 2012, what is the difference between the Balance of Payment (as % of commercial service exports) in Mozambique and Balance of Payment (as % of commercial service exports) in New Zealand?
Your answer should be very brief. -29.55. In the year 2013, what is the difference between the Balance of Payment (as % of commercial service exports) of Azerbaijan and Balance of Payment (as % of commercial service exports) of Mozambique?
Offer a terse response. 34.01. In the year 2013, what is the difference between the Balance of Payment (as % of commercial service exports) of Azerbaijan and Balance of Payment (as % of commercial service exports) of New Zealand?
Offer a very short reply. 1.38. In the year 2013, what is the difference between the Balance of Payment (as % of commercial service exports) in Mozambique and Balance of Payment (as % of commercial service exports) in New Zealand?
Your response must be concise. -32.63. What is the ratio of the Balance of Payment (as % of commercial service exports) in Azerbaijan in 2006 to that in 2007?
Offer a very short reply. 1.05. What is the ratio of the Balance of Payment (as % of commercial service exports) of New Zealand in 2006 to that in 2007?
Make the answer very short. 1.01. What is the ratio of the Balance of Payment (as % of commercial service exports) of Azerbaijan in 2006 to that in 2008?
Your response must be concise. 1.11. What is the ratio of the Balance of Payment (as % of commercial service exports) in Mozambique in 2006 to that in 2008?
Give a very brief answer. 0.82. What is the ratio of the Balance of Payment (as % of commercial service exports) of New Zealand in 2006 to that in 2008?
Give a very brief answer. 1.06. What is the ratio of the Balance of Payment (as % of commercial service exports) of Azerbaijan in 2006 to that in 2009?
Make the answer very short. 0.72. What is the ratio of the Balance of Payment (as % of commercial service exports) in Mozambique in 2006 to that in 2009?
Offer a very short reply. 1.1. What is the ratio of the Balance of Payment (as % of commercial service exports) in New Zealand in 2006 to that in 2009?
Keep it short and to the point. 1.06. What is the ratio of the Balance of Payment (as % of commercial service exports) of Azerbaijan in 2006 to that in 2010?
Your response must be concise. 0.49. What is the ratio of the Balance of Payment (as % of commercial service exports) of Mozambique in 2006 to that in 2010?
Provide a succinct answer. 1.11. What is the ratio of the Balance of Payment (as % of commercial service exports) in New Zealand in 2006 to that in 2010?
Your response must be concise. 1.11. What is the ratio of the Balance of Payment (as % of commercial service exports) in Azerbaijan in 2006 to that in 2011?
Provide a short and direct response. 0.31. What is the ratio of the Balance of Payment (as % of commercial service exports) of Mozambique in 2006 to that in 2011?
Your response must be concise. 1.13. What is the ratio of the Balance of Payment (as % of commercial service exports) of New Zealand in 2006 to that in 2011?
Your response must be concise. 1.13. What is the ratio of the Balance of Payment (as % of commercial service exports) in Azerbaijan in 2006 to that in 2012?
Provide a short and direct response. 0.26. What is the ratio of the Balance of Payment (as % of commercial service exports) in Mozambique in 2006 to that in 2012?
Make the answer very short. 1.55. What is the ratio of the Balance of Payment (as % of commercial service exports) in New Zealand in 2006 to that in 2012?
Ensure brevity in your answer.  1.15. What is the ratio of the Balance of Payment (as % of commercial service exports) of Azerbaijan in 2006 to that in 2013?
Provide a short and direct response. 0.23. What is the ratio of the Balance of Payment (as % of commercial service exports) of Mozambique in 2006 to that in 2013?
Keep it short and to the point. 1.67. What is the ratio of the Balance of Payment (as % of commercial service exports) of New Zealand in 2006 to that in 2013?
Your answer should be very brief. 1.12. What is the ratio of the Balance of Payment (as % of commercial service exports) in Azerbaijan in 2007 to that in 2008?
Provide a short and direct response. 1.06. What is the ratio of the Balance of Payment (as % of commercial service exports) of Mozambique in 2007 to that in 2008?
Provide a short and direct response. 0.84. What is the ratio of the Balance of Payment (as % of commercial service exports) in New Zealand in 2007 to that in 2008?
Keep it short and to the point. 1.05. What is the ratio of the Balance of Payment (as % of commercial service exports) in Azerbaijan in 2007 to that in 2009?
Offer a terse response. 0.69. What is the ratio of the Balance of Payment (as % of commercial service exports) in Mozambique in 2007 to that in 2009?
Offer a terse response. 1.12. What is the ratio of the Balance of Payment (as % of commercial service exports) in New Zealand in 2007 to that in 2009?
Give a very brief answer. 1.06. What is the ratio of the Balance of Payment (as % of commercial service exports) in Azerbaijan in 2007 to that in 2010?
Ensure brevity in your answer.  0.47. What is the ratio of the Balance of Payment (as % of commercial service exports) in Mozambique in 2007 to that in 2010?
Give a very brief answer. 1.14. What is the ratio of the Balance of Payment (as % of commercial service exports) of New Zealand in 2007 to that in 2010?
Provide a short and direct response. 1.1. What is the ratio of the Balance of Payment (as % of commercial service exports) in Azerbaijan in 2007 to that in 2011?
Your answer should be compact. 0.29. What is the ratio of the Balance of Payment (as % of commercial service exports) in Mozambique in 2007 to that in 2011?
Your answer should be compact. 1.15. What is the ratio of the Balance of Payment (as % of commercial service exports) of New Zealand in 2007 to that in 2011?
Your answer should be compact. 1.12. What is the ratio of the Balance of Payment (as % of commercial service exports) of Azerbaijan in 2007 to that in 2012?
Your response must be concise. 0.25. What is the ratio of the Balance of Payment (as % of commercial service exports) of Mozambique in 2007 to that in 2012?
Keep it short and to the point. 1.59. What is the ratio of the Balance of Payment (as % of commercial service exports) of New Zealand in 2007 to that in 2012?
Offer a terse response. 1.14. What is the ratio of the Balance of Payment (as % of commercial service exports) of Azerbaijan in 2007 to that in 2013?
Make the answer very short. 0.22. What is the ratio of the Balance of Payment (as % of commercial service exports) of Mozambique in 2007 to that in 2013?
Offer a terse response. 1.71. What is the ratio of the Balance of Payment (as % of commercial service exports) of New Zealand in 2007 to that in 2013?
Your answer should be very brief. 1.11. What is the ratio of the Balance of Payment (as % of commercial service exports) of Azerbaijan in 2008 to that in 2009?
Offer a very short reply. 0.65. What is the ratio of the Balance of Payment (as % of commercial service exports) of Mozambique in 2008 to that in 2009?
Your answer should be very brief. 1.34. What is the ratio of the Balance of Payment (as % of commercial service exports) of Azerbaijan in 2008 to that in 2010?
Your answer should be very brief. 0.44. What is the ratio of the Balance of Payment (as % of commercial service exports) in Mozambique in 2008 to that in 2010?
Offer a terse response. 1.36. What is the ratio of the Balance of Payment (as % of commercial service exports) of New Zealand in 2008 to that in 2010?
Ensure brevity in your answer.  1.04. What is the ratio of the Balance of Payment (as % of commercial service exports) of Azerbaijan in 2008 to that in 2011?
Your response must be concise. 0.28. What is the ratio of the Balance of Payment (as % of commercial service exports) of Mozambique in 2008 to that in 2011?
Keep it short and to the point. 1.38. What is the ratio of the Balance of Payment (as % of commercial service exports) of New Zealand in 2008 to that in 2011?
Ensure brevity in your answer.  1.07. What is the ratio of the Balance of Payment (as % of commercial service exports) in Azerbaijan in 2008 to that in 2012?
Keep it short and to the point. 0.23. What is the ratio of the Balance of Payment (as % of commercial service exports) in Mozambique in 2008 to that in 2012?
Make the answer very short. 1.89. What is the ratio of the Balance of Payment (as % of commercial service exports) in New Zealand in 2008 to that in 2012?
Offer a terse response. 1.08. What is the ratio of the Balance of Payment (as % of commercial service exports) in Azerbaijan in 2008 to that in 2013?
Make the answer very short. 0.21. What is the ratio of the Balance of Payment (as % of commercial service exports) in Mozambique in 2008 to that in 2013?
Make the answer very short. 2.05. What is the ratio of the Balance of Payment (as % of commercial service exports) of New Zealand in 2008 to that in 2013?
Provide a succinct answer. 1.06. What is the ratio of the Balance of Payment (as % of commercial service exports) in Azerbaijan in 2009 to that in 2010?
Ensure brevity in your answer.  0.68. What is the ratio of the Balance of Payment (as % of commercial service exports) in Mozambique in 2009 to that in 2010?
Provide a succinct answer. 1.01. What is the ratio of the Balance of Payment (as % of commercial service exports) of New Zealand in 2009 to that in 2010?
Ensure brevity in your answer.  1.04. What is the ratio of the Balance of Payment (as % of commercial service exports) of Azerbaijan in 2009 to that in 2011?
Your response must be concise. 0.43. What is the ratio of the Balance of Payment (as % of commercial service exports) in Mozambique in 2009 to that in 2011?
Keep it short and to the point. 1.03. What is the ratio of the Balance of Payment (as % of commercial service exports) of New Zealand in 2009 to that in 2011?
Provide a short and direct response. 1.06. What is the ratio of the Balance of Payment (as % of commercial service exports) in Azerbaijan in 2009 to that in 2012?
Provide a succinct answer. 0.36. What is the ratio of the Balance of Payment (as % of commercial service exports) of Mozambique in 2009 to that in 2012?
Your response must be concise. 1.41. What is the ratio of the Balance of Payment (as % of commercial service exports) of New Zealand in 2009 to that in 2012?
Offer a terse response. 1.08. What is the ratio of the Balance of Payment (as % of commercial service exports) of Azerbaijan in 2009 to that in 2013?
Provide a succinct answer. 0.33. What is the ratio of the Balance of Payment (as % of commercial service exports) in Mozambique in 2009 to that in 2013?
Ensure brevity in your answer.  1.52. What is the ratio of the Balance of Payment (as % of commercial service exports) in New Zealand in 2009 to that in 2013?
Your response must be concise. 1.05. What is the ratio of the Balance of Payment (as % of commercial service exports) in Azerbaijan in 2010 to that in 2011?
Offer a very short reply. 0.63. What is the ratio of the Balance of Payment (as % of commercial service exports) in New Zealand in 2010 to that in 2011?
Give a very brief answer. 1.02. What is the ratio of the Balance of Payment (as % of commercial service exports) of Azerbaijan in 2010 to that in 2012?
Provide a succinct answer. 0.53. What is the ratio of the Balance of Payment (as % of commercial service exports) in Mozambique in 2010 to that in 2012?
Give a very brief answer. 1.39. What is the ratio of the Balance of Payment (as % of commercial service exports) of New Zealand in 2010 to that in 2012?
Offer a very short reply. 1.04. What is the ratio of the Balance of Payment (as % of commercial service exports) of Azerbaijan in 2010 to that in 2013?
Your response must be concise. 0.48. What is the ratio of the Balance of Payment (as % of commercial service exports) of Mozambique in 2010 to that in 2013?
Offer a very short reply. 1.5. What is the ratio of the Balance of Payment (as % of commercial service exports) in New Zealand in 2010 to that in 2013?
Your response must be concise. 1.01. What is the ratio of the Balance of Payment (as % of commercial service exports) in Azerbaijan in 2011 to that in 2012?
Offer a terse response. 0.84. What is the ratio of the Balance of Payment (as % of commercial service exports) in Mozambique in 2011 to that in 2012?
Ensure brevity in your answer.  1.37. What is the ratio of the Balance of Payment (as % of commercial service exports) of New Zealand in 2011 to that in 2012?
Offer a very short reply. 1.01. What is the ratio of the Balance of Payment (as % of commercial service exports) in Azerbaijan in 2011 to that in 2013?
Provide a succinct answer. 0.76. What is the ratio of the Balance of Payment (as % of commercial service exports) of Mozambique in 2011 to that in 2013?
Offer a terse response. 1.49. What is the ratio of the Balance of Payment (as % of commercial service exports) of New Zealand in 2011 to that in 2013?
Your answer should be very brief. 0.99. What is the ratio of the Balance of Payment (as % of commercial service exports) in Azerbaijan in 2012 to that in 2013?
Provide a succinct answer. 0.9. What is the ratio of the Balance of Payment (as % of commercial service exports) of Mozambique in 2012 to that in 2013?
Provide a succinct answer. 1.08. What is the ratio of the Balance of Payment (as % of commercial service exports) of New Zealand in 2012 to that in 2013?
Offer a terse response. 0.98. What is the difference between the highest and the second highest Balance of Payment (as % of commercial service exports) of Azerbaijan?
Provide a succinct answer. 5.61. What is the difference between the highest and the second highest Balance of Payment (as % of commercial service exports) of Mozambique?
Keep it short and to the point. 7.82. What is the difference between the highest and the second highest Balance of Payment (as % of commercial service exports) of New Zealand?
Provide a short and direct response. 0.55. What is the difference between the highest and the lowest Balance of Payment (as % of commercial service exports) of Azerbaijan?
Provide a succinct answer. 45.46. What is the difference between the highest and the lowest Balance of Payment (as % of commercial service exports) in Mozambique?
Give a very brief answer. 24.65. What is the difference between the highest and the lowest Balance of Payment (as % of commercial service exports) of New Zealand?
Keep it short and to the point. 8.1. 